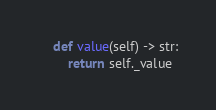<code> <loc_0><loc_0><loc_500><loc_500><_Python_>    def value(self) -> str:
        return self._value
</code> 